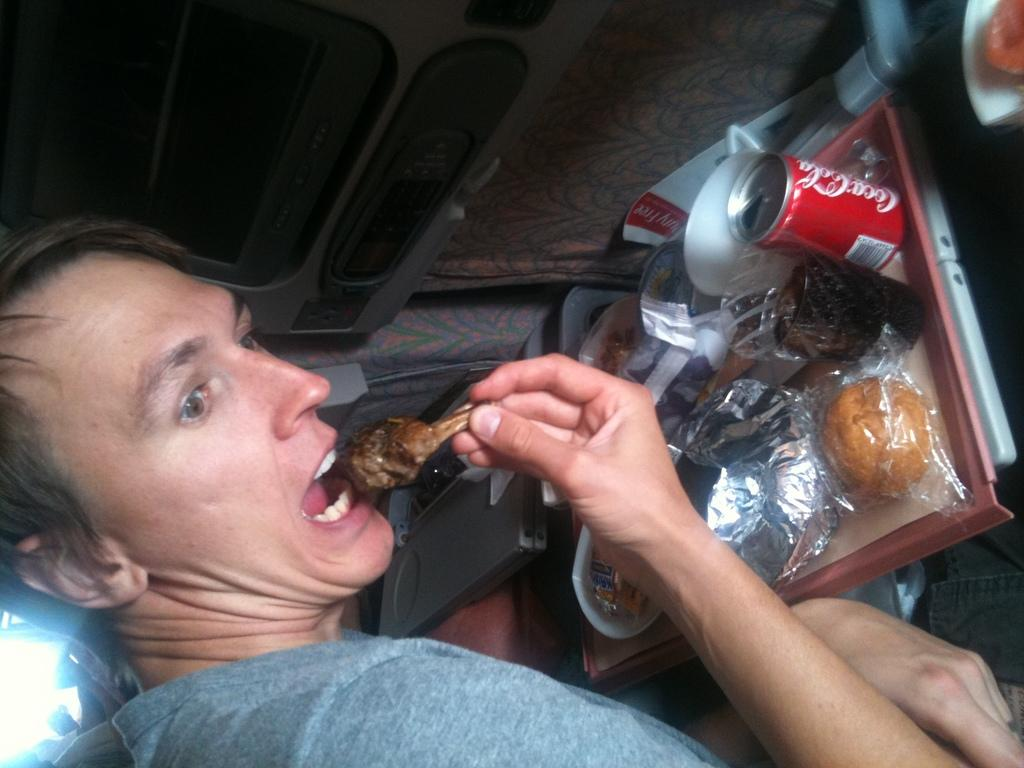Who is present in the image? There is a man in the image. What is the man holding in the image? The man is holding food in the image. What type of beverage container can be seen in the image? There is a coke tin in the image. Can you describe any other objects in the image? There are some unspecified objects in the image. What color is the stocking on the hydrant in the image? There is no stocking or hydrant present in the image. 